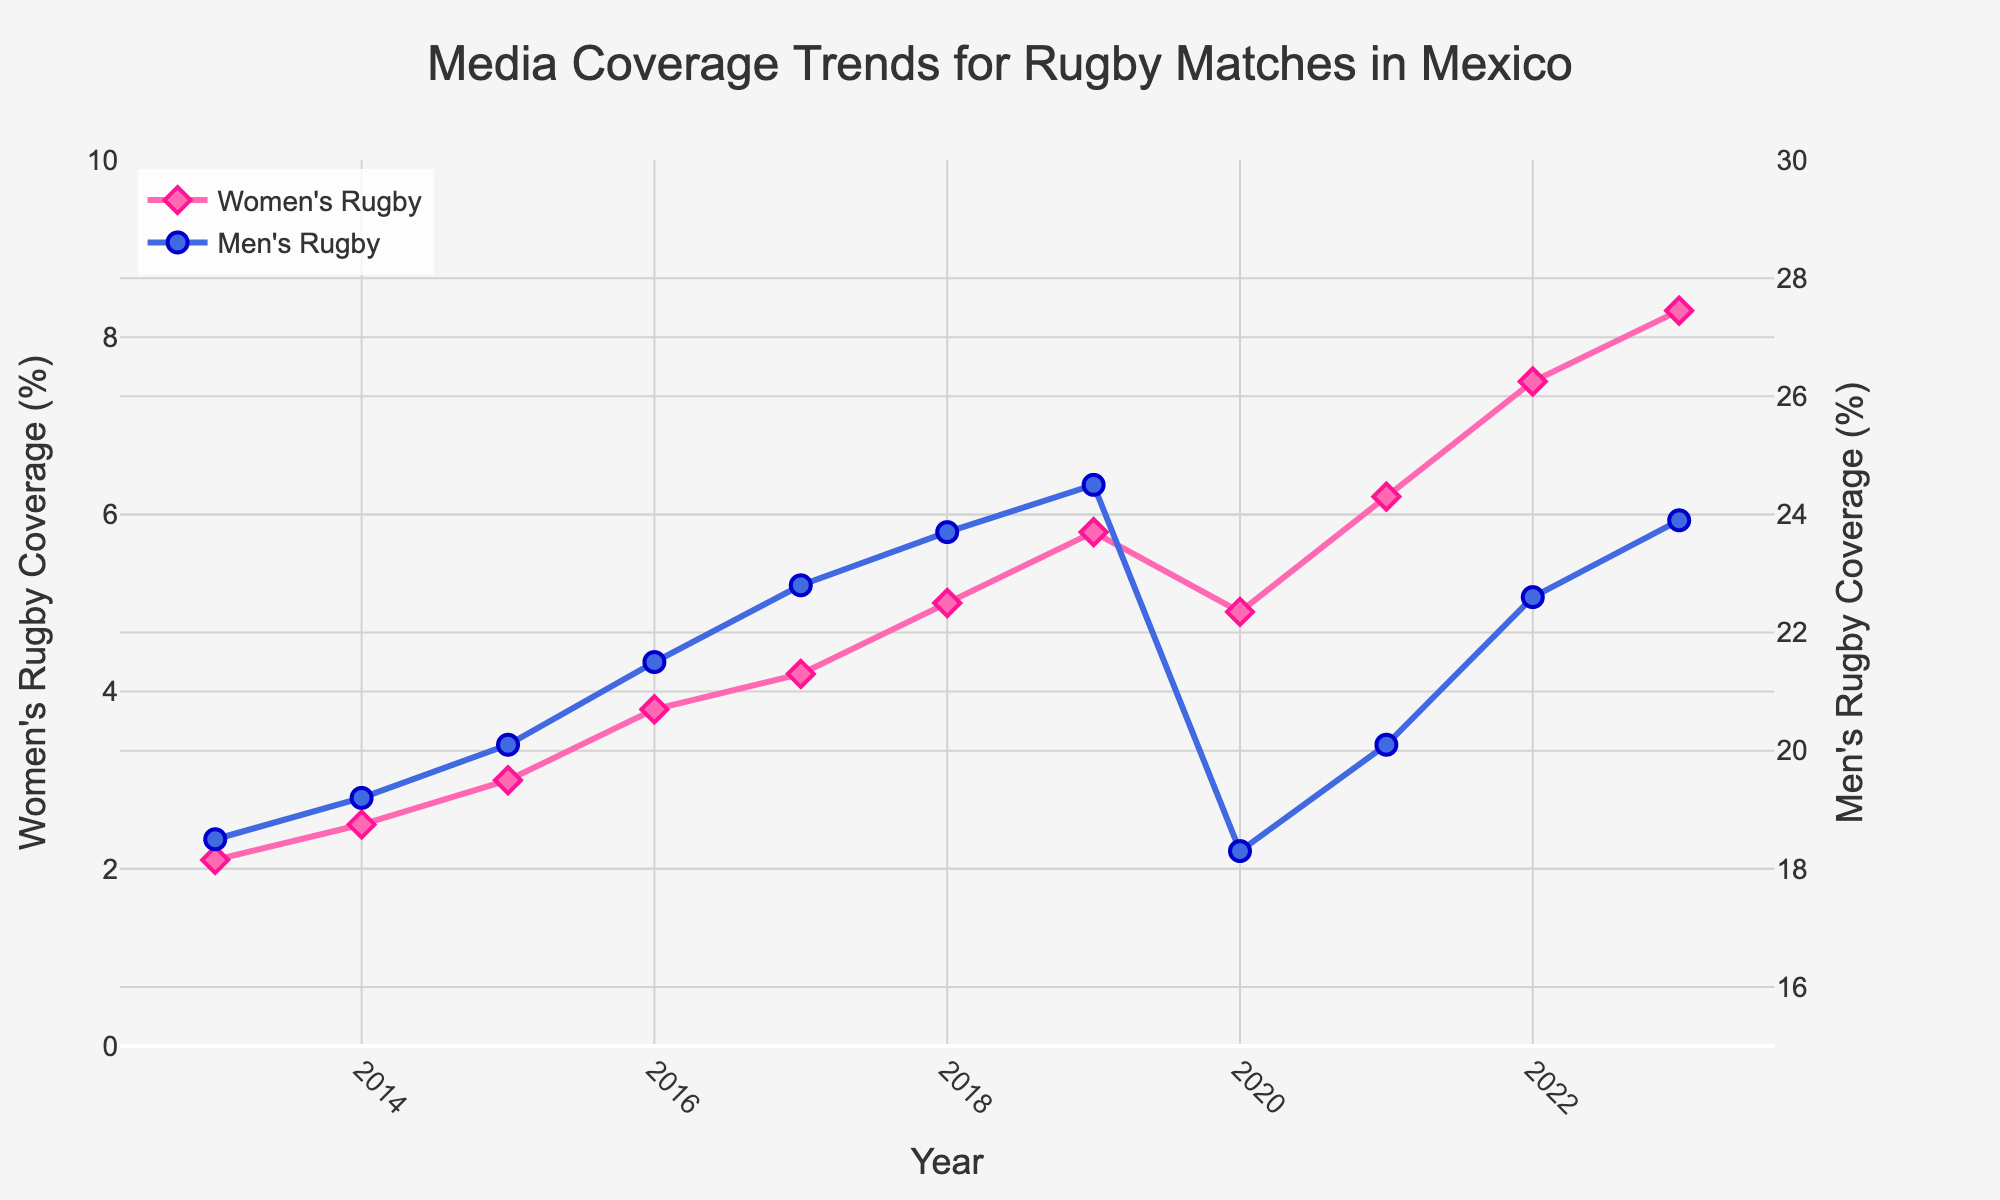Which year shows the highest media coverage for women's rugby matches? The year with the highest media coverage can be identified by looking at the peak of the pink line. The peak occurs in 2023.
Answer: 2023 In which year did men's rugby matches experience a noticeable drop in media coverage? Noticeable drops in media coverage can be identified by observing a downward trend in the blue line. This occurs from 2019 to 2020. Therefore, the significant drop is in 2020.
Answer: 2020 How much did the media coverage for women's rugby matches increase from 2013 to 2023? The coverage in 2013 was 2.1% and in 2023 it is 8.3%. The increase can be calculated as 8.3% - 2.1% = 6.2%.
Answer: 6.2% By how much did media coverage for men's rugby matches decrease between 2019 and 2020? The coverage in 2019 was 24.5% and decreased to 18.3% in 2020. The decrease can be calculated as 24.5% - 18.3% = 6.2%.
Answer: 6.2% Compare the media coverage trends for men's and women's rugby from 2015 to 2018. Which one increased more and by how much? For women's rugby, media coverage increased from 3.0% in 2015 to 5.0% in 2018, an increase of 2.0%. For men's rugby, it increased from 20.1% to 23.7%, an increase of 3.6%. Therefore, men's rugby coverage increased more by 1.6%.
Answer: Men's rugby by 1.6% What was the media coverage for women's rugby matches in 2020, and how does it compare to the media coverage for men's rugby matches in the same year? In 2020, women's rugby had a coverage of 4.9%, while men's rugby had 18.3%. Comparing these, we can see that men's rugby coverage was higher by 18.3% - 4.9% = 13.4%.
Answer: Men's rugby higher by 13.4% What is the difference in the media coverage percentage points between men’s and women’s rugby matches in 2023? In 2023, the media coverage for women's rugby is 8.3%, and for men’s rugby, it's 23.9%. The difference is 23.9% - 8.3% = 15.6%.
Answer: 15.6% Identify the general trend in media coverage for women's rugby matches from 2013 to 2023. To identify the trend, observe the pink line's progression from 2013 to 2023. The line shows a consistent upward trend, indicating an overall increase in media coverage.
Answer: Increasing When did the women's rugby matches' media coverage first surpass 5%? By looking at the pink line, we see that the first time the coverage surpasses 5% is in 2018.
Answer: 2018 Estimate the average media coverage for men's rugby matches over the decade. The average can be estimated by summing the yearly values and dividing by the number of years: (18.5 + 19.2 + 20.1 + 21.5 + 22.8 + 23.7 + 24.5 + 18.3 + 20.1 + 22.6 + 23.9) / 11 ≈ 21.2%.
Answer: 21.2% 